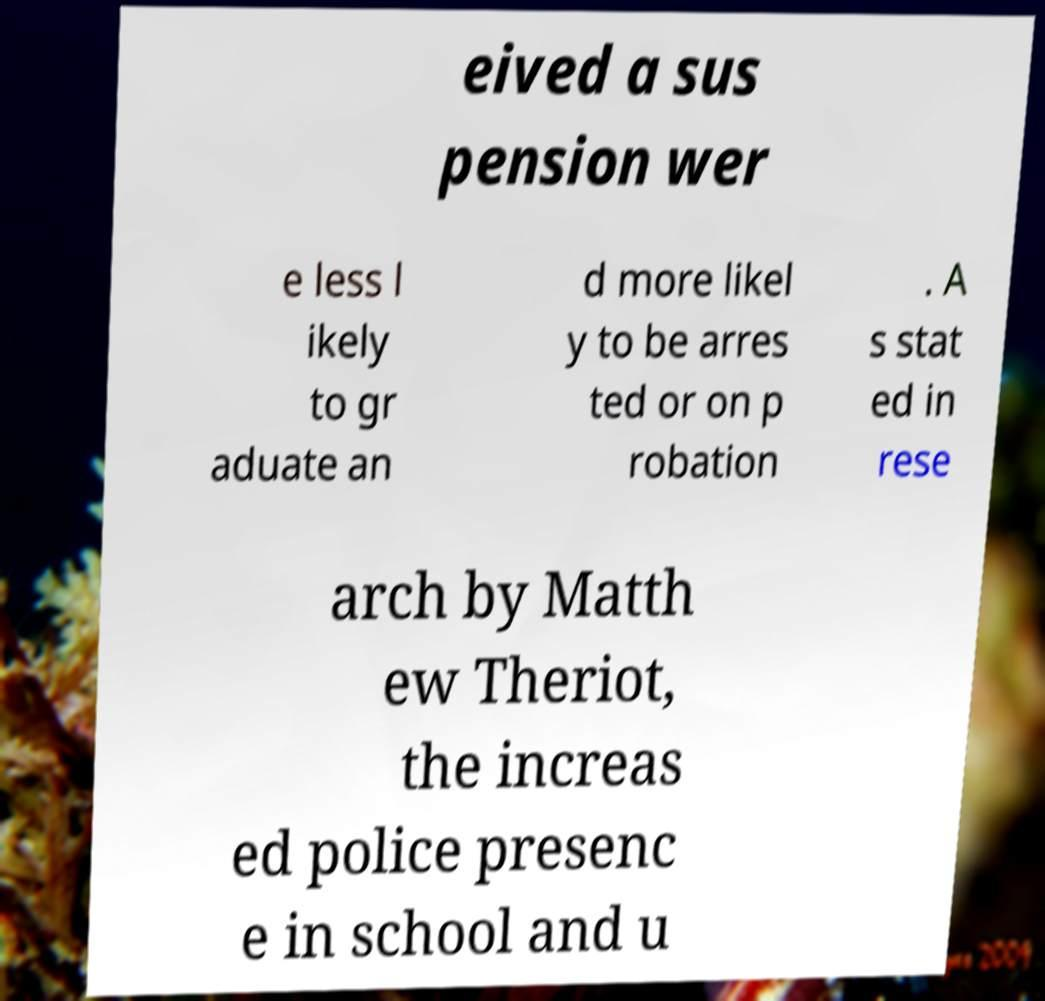Could you extract and type out the text from this image? eived a sus pension wer e less l ikely to gr aduate an d more likel y to be arres ted or on p robation . A s stat ed in rese arch by Matth ew Theriot, the increas ed police presenc e in school and u 